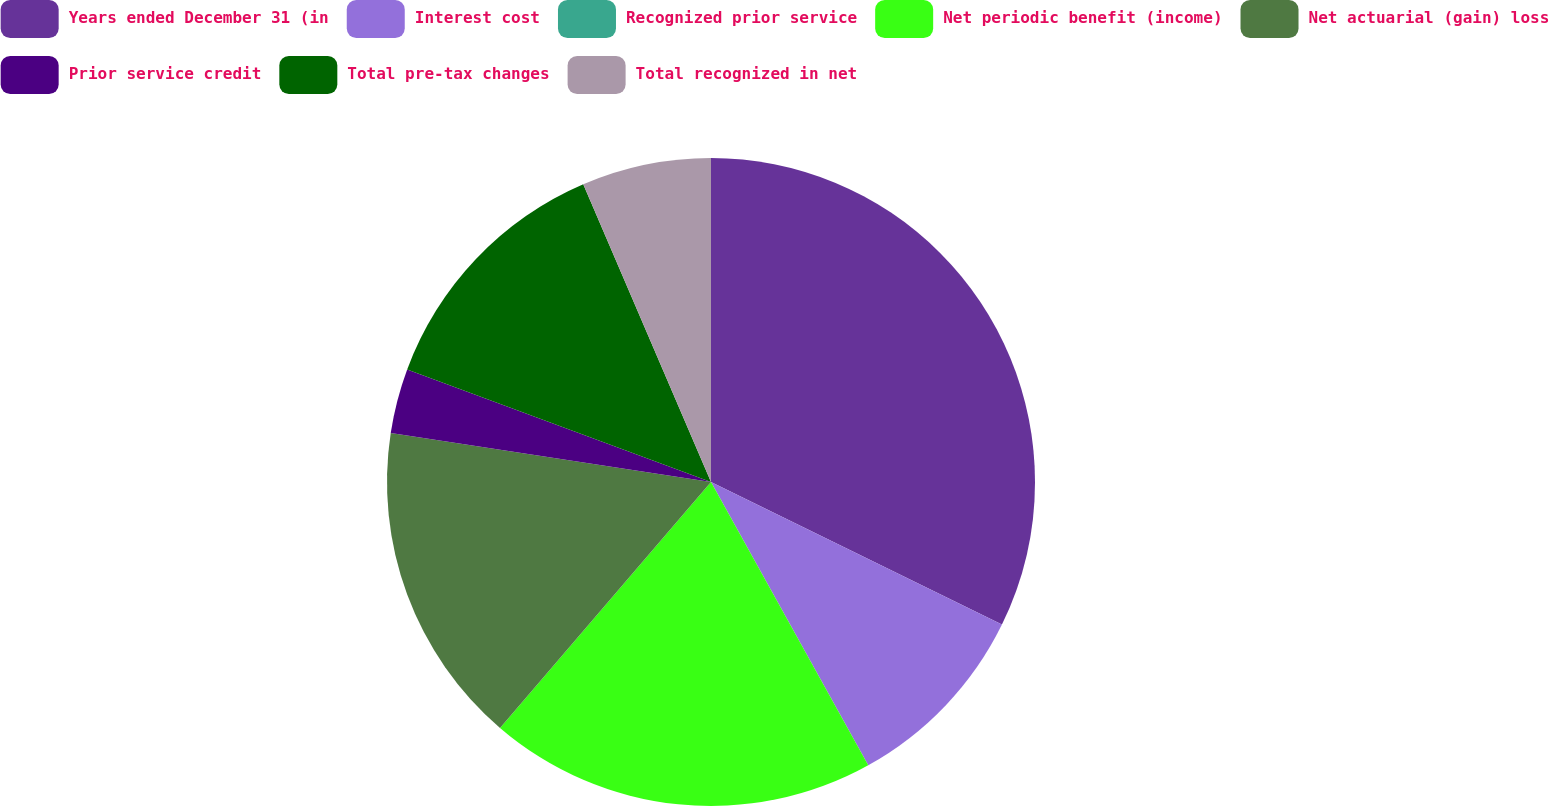<chart> <loc_0><loc_0><loc_500><loc_500><pie_chart><fcel>Years ended December 31 (in<fcel>Interest cost<fcel>Recognized prior service<fcel>Net periodic benefit (income)<fcel>Net actuarial (gain) loss<fcel>Prior service credit<fcel>Total pre-tax changes<fcel>Total recognized in net<nl><fcel>32.25%<fcel>9.68%<fcel>0.0%<fcel>19.35%<fcel>16.13%<fcel>3.23%<fcel>12.9%<fcel>6.45%<nl></chart> 